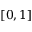Convert formula to latex. <formula><loc_0><loc_0><loc_500><loc_500>[ 0 , 1 ]</formula> 